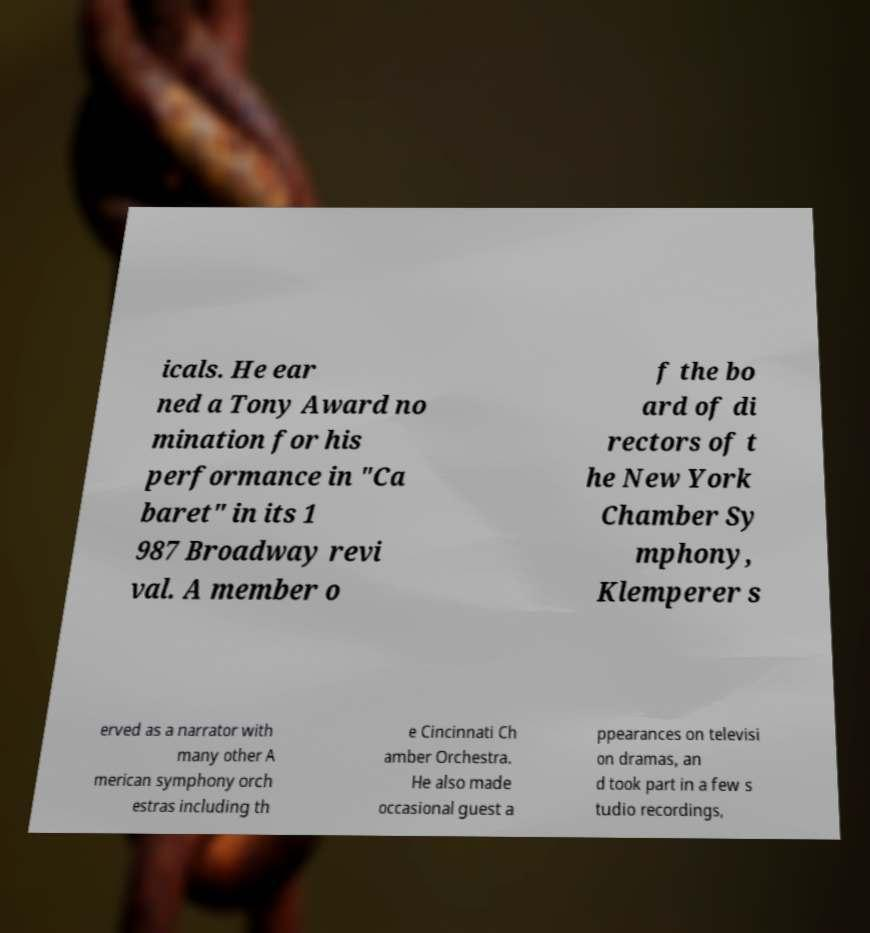I need the written content from this picture converted into text. Can you do that? icals. He ear ned a Tony Award no mination for his performance in "Ca baret" in its 1 987 Broadway revi val. A member o f the bo ard of di rectors of t he New York Chamber Sy mphony, Klemperer s erved as a narrator with many other A merican symphony orch estras including th e Cincinnati Ch amber Orchestra. He also made occasional guest a ppearances on televisi on dramas, an d took part in a few s tudio recordings, 